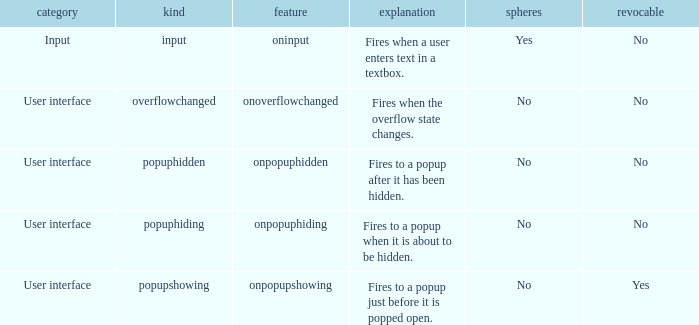 how many bubbles with category being input 1.0. 